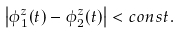Convert formula to latex. <formula><loc_0><loc_0><loc_500><loc_500>\left | \phi _ { 1 } ^ { z } ( t ) - \phi _ { 2 } ^ { z } ( t ) \right | < c o n s t .</formula> 